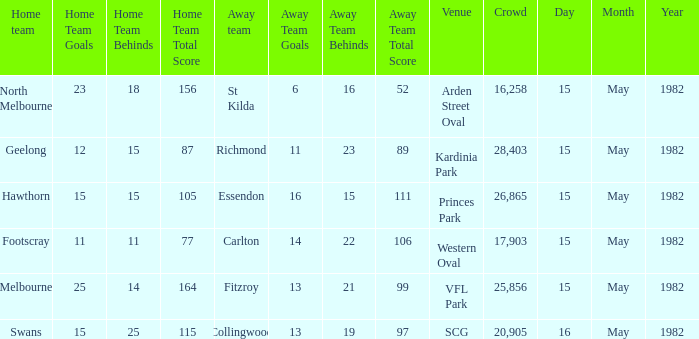Where did Geelong play as the home team? Kardinia Park. 